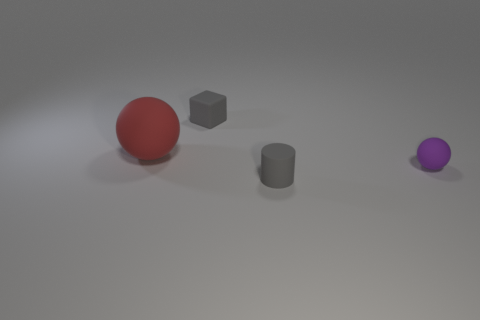Are the small gray thing behind the tiny rubber cylinder and the tiny object on the right side of the gray rubber cylinder made of the same material? Based on the visual characteristics such as color, texture, and apparent surface reflection, it appears that both the small gray object behind the tiny rubber cylinder and the tiny object on the right side of that cylinder may indeed be made of similar, if not the same, material, likely some type of plastic or rubber commonly used in such 3D renderings. 